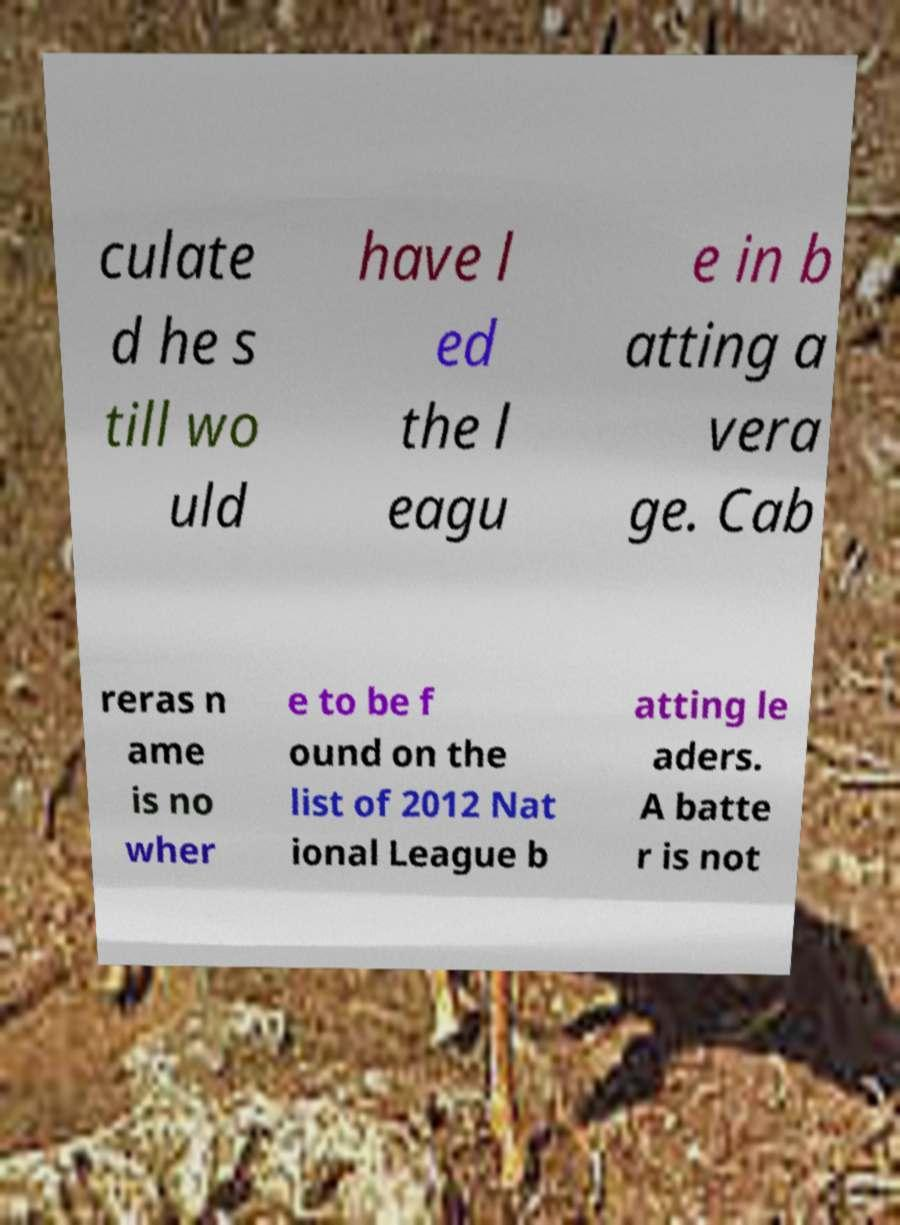There's text embedded in this image that I need extracted. Can you transcribe it verbatim? culate d he s till wo uld have l ed the l eagu e in b atting a vera ge. Cab reras n ame is no wher e to be f ound on the list of 2012 Nat ional League b atting le aders. A batte r is not 